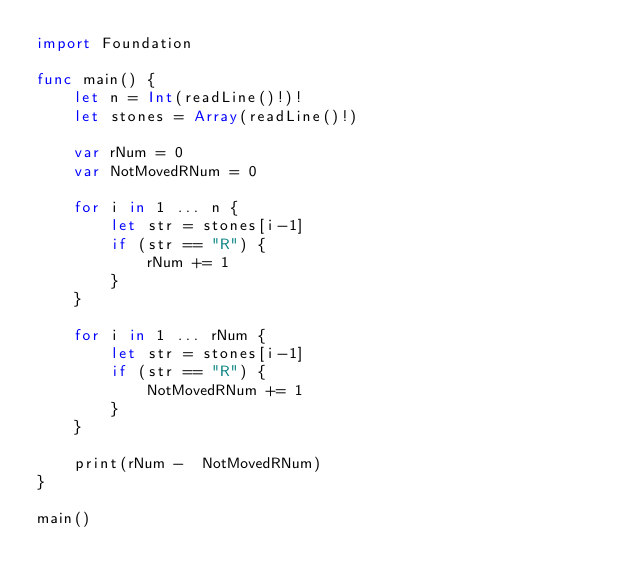<code> <loc_0><loc_0><loc_500><loc_500><_Swift_>import Foundation

func main() {
    let n = Int(readLine()!)!
    let stones = Array(readLine()!)
    
    var rNum = 0
    var NotMovedRNum = 0
    
    for i in 1 ... n {
        let str = stones[i-1]
        if (str == "R") {
            rNum += 1
        } 
    }
    
    for i in 1 ... rNum {
        let str = stones[i-1]
        if (str == "R") {
            NotMovedRNum += 1
        } 
    }

    print(rNum -  NotMovedRNum)
}

main()</code> 